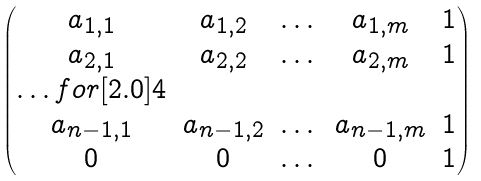Convert formula to latex. <formula><loc_0><loc_0><loc_500><loc_500>\begin{pmatrix} a _ { 1 , 1 } & a _ { 1 , 2 } & \dots & a _ { 1 , m } & 1 \\ a _ { 2 , 1 } & a _ { 2 , 2 } & \dots & a _ { 2 , m } & 1 \\ \hdots f o r [ 2 . 0 ] 4 \\ a _ { n - 1 , 1 } & a _ { n - 1 , 2 } & \dots & a _ { n - 1 , m } & 1 \\ 0 & 0 & \dots & 0 & 1 \end{pmatrix}</formula> 